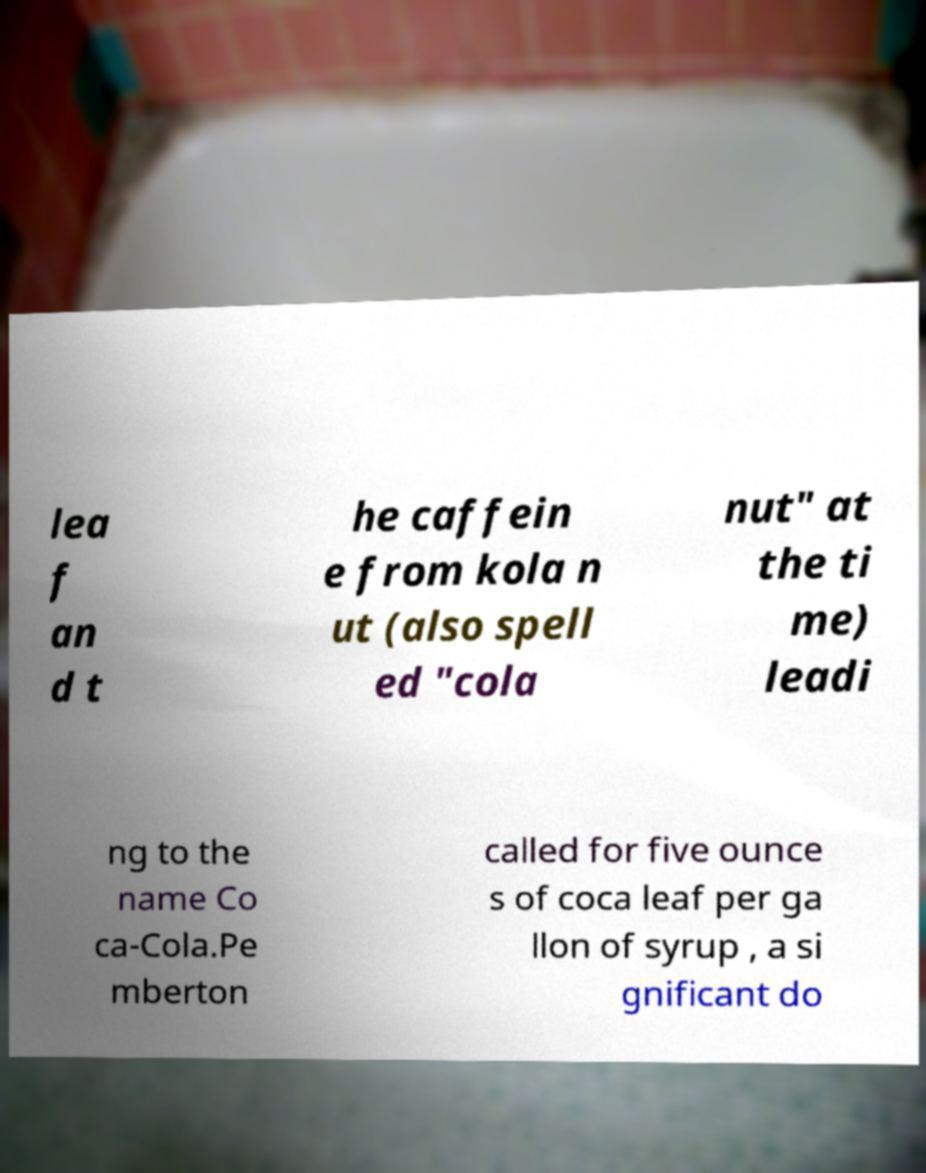I need the written content from this picture converted into text. Can you do that? lea f an d t he caffein e from kola n ut (also spell ed "cola nut" at the ti me) leadi ng to the name Co ca-Cola.Pe mberton called for five ounce s of coca leaf per ga llon of syrup , a si gnificant do 